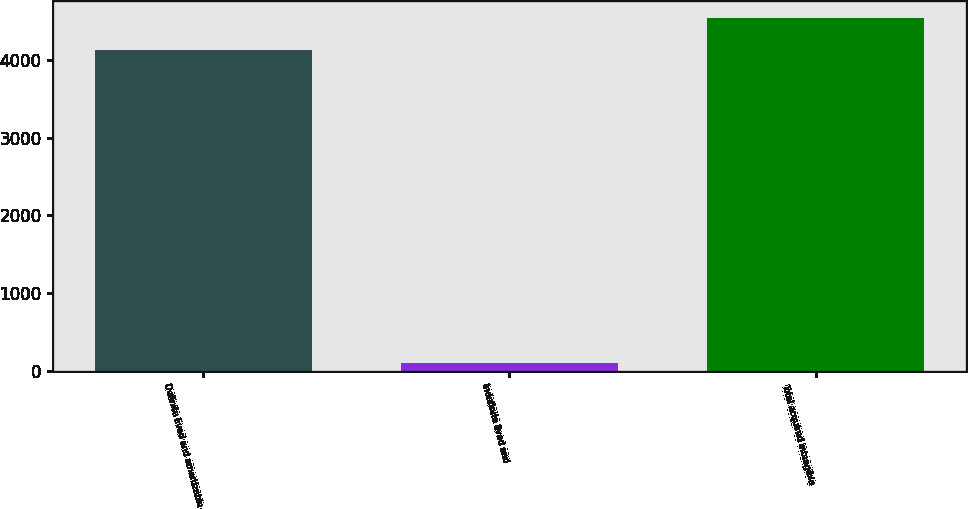Convert chart to OTSL. <chart><loc_0><loc_0><loc_500><loc_500><bar_chart><fcel>Definite lived and amortizable<fcel>Indefinite lived and<fcel>Total acquired intangible<nl><fcel>4124<fcel>100<fcel>4536.4<nl></chart> 